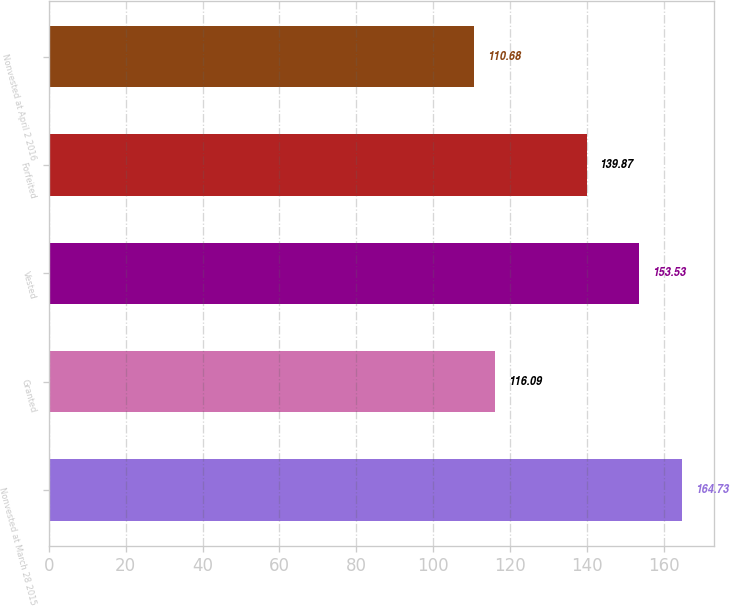<chart> <loc_0><loc_0><loc_500><loc_500><bar_chart><fcel>Nonvested at March 28 2015<fcel>Granted<fcel>Vested<fcel>Forfeited<fcel>Nonvested at April 2 2016<nl><fcel>164.73<fcel>116.09<fcel>153.53<fcel>139.87<fcel>110.68<nl></chart> 